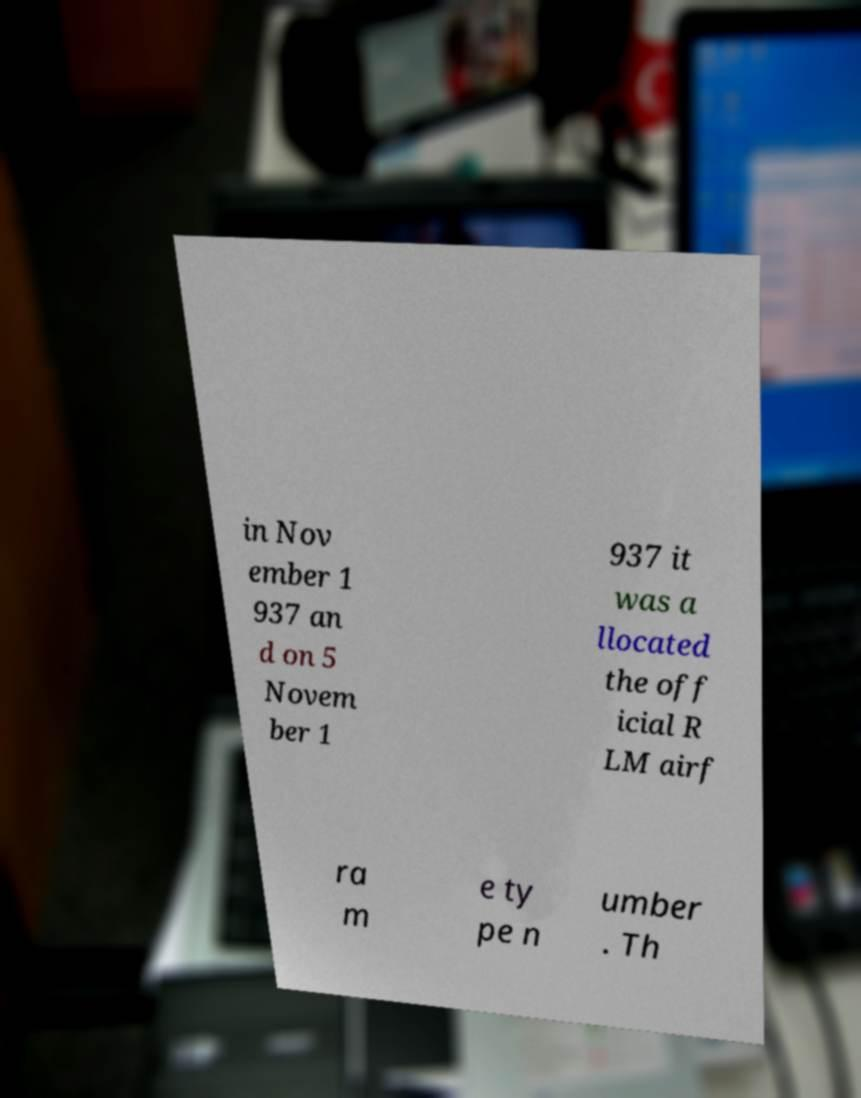I need the written content from this picture converted into text. Can you do that? in Nov ember 1 937 an d on 5 Novem ber 1 937 it was a llocated the off icial R LM airf ra m e ty pe n umber . Th 